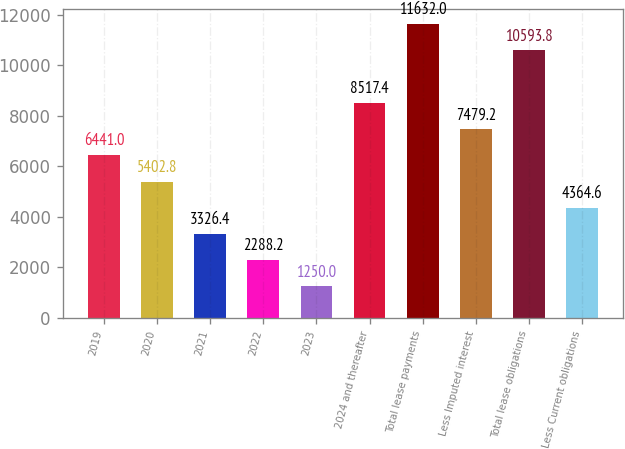Convert chart to OTSL. <chart><loc_0><loc_0><loc_500><loc_500><bar_chart><fcel>2019<fcel>2020<fcel>2021<fcel>2022<fcel>2023<fcel>2024 and thereafter<fcel>Total lease payments<fcel>Less Imputed interest<fcel>Total lease obligations<fcel>Less Current obligations<nl><fcel>6441<fcel>5402.8<fcel>3326.4<fcel>2288.2<fcel>1250<fcel>8517.4<fcel>11632<fcel>7479.2<fcel>10593.8<fcel>4364.6<nl></chart> 